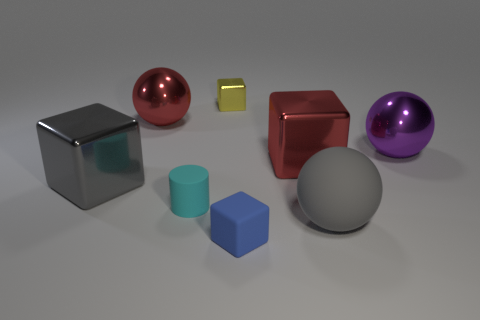Subtract all rubber cubes. How many cubes are left? 3 Subtract 1 spheres. How many spheres are left? 2 Subtract all green cubes. Subtract all purple cylinders. How many cubes are left? 4 Add 2 brown rubber things. How many objects exist? 10 Subtract all spheres. How many objects are left? 5 Add 2 blue rubber objects. How many blue rubber objects are left? 3 Add 6 tiny cyan cylinders. How many tiny cyan cylinders exist? 7 Subtract 0 brown cylinders. How many objects are left? 8 Subtract all cyan matte things. Subtract all rubber objects. How many objects are left? 4 